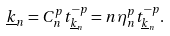<formula> <loc_0><loc_0><loc_500><loc_500>\underline { k } _ { n } = C _ { n } ^ { p } t _ { \underline { k } _ { n } } ^ { - p } = n \eta _ { n } ^ { p } t _ { \underline { k } _ { n } } ^ { - p } .</formula> 